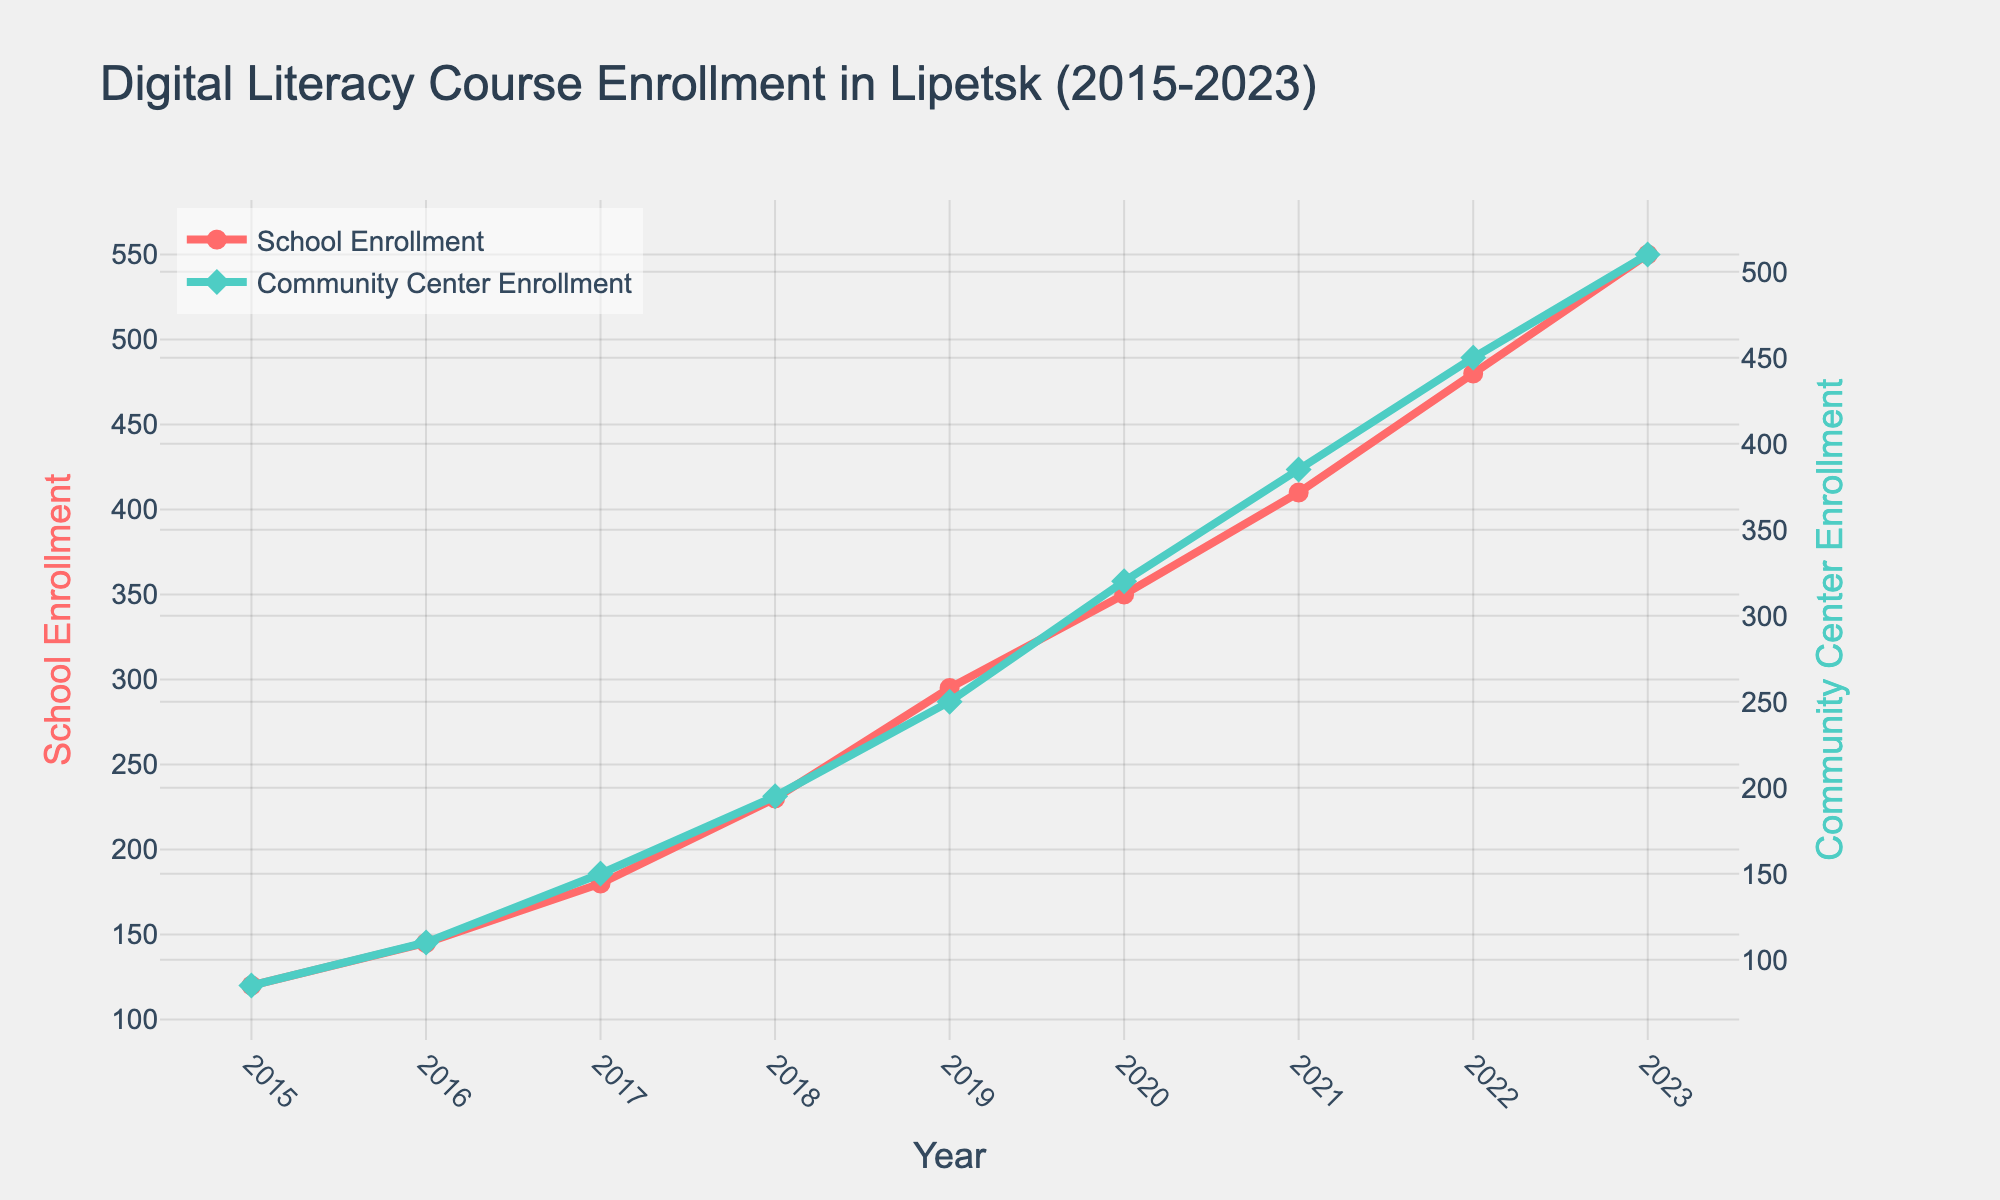Which year had the highest school enrollment? From the figure, identify the year with the peak value on the red line representing school enrollment. The highest point corresponds to 2023 with an enrollment of 550.
Answer: 2023 Which year had the highest community center enrollment? From the figure, identify the year with the peak value on the turquoise line representing community center enrollment. The highest point corresponds to 2023 with an enrollment of 510.
Answer: 2023 In which year did the school enrollment surpass 300 for the first time? Locate the red line indicating school enrollment and find the year when the value first exceeds 300. The year is 2020 with an enrollment of 350.
Answer: 2020 What is the difference between school enrollment and community center enrollment in 2023? Look at the enrollment values for both schools and community centers in 2023. The difference is 550 - 510 = 40.
Answer: 40 What was the community center enrollment in 2018? Find the value on the turquoise line for the year 2018. The community center enrollment in 2018 is 195.
Answer: 195 How does the growth in school enrollment from 2015 to 2023 compare with the growth in community center enrollment over the same period? Calculate the differences between 2023 and 2015 for both enrollment types. For schools: 550 - 120 = 430. For community centers: 510 - 85 = 425. Both show substantial growth, with schools slightly higher.
Answer: School enrollment growth: 430, Community center enrollment growth: 425 Which year saw the highest increase in school enrollment compared to the previous year? Calculate the yearly increase and find the maximum. Increments are: 
2015-2016: 145-120=25,
2016-2017: 180-145=35,
2017-2018: 230-180=50,
2018-2019: 295-230=65,
2019-2020: 350-295=55,
2020-2021: 410-350=60,
2021-2022: 480-410=70,
2022-2023: 550-480=70.
2021-2022 and 2022-2023 both had the highest increase of 70 students.
Answer: 2021-2022 and 2022-2023 What is the average annual community center enrollment from 2015 to 2023? Sum the community center enrollments from each year and divide by the number of years (9). The sum is 85+110+150+195+250+320+385+450+510 = 2455. The average is 2455/9 ≈ 272.8.
Answer: 272.8 Which enrollment was higher in 2017, school or community center? Compare the values for the year 2017. School enrollment is 180 and community center enrollment is 150. Hence, school enrollment was higher.
Answer: School enrollment Between which consecutive years did community center enrollment grow the most? Calculate the year-over-year changes for community center enrollments and find the maximum increment. 
2015-2016: 110-85=25,
2016-2017: 150-110=40,
2017-2018: 195-150=45,
2018-2019: 250-195=55,
2019-2020: 320-250=70,
2020-2021: 385-320=65,
2021-2022: 450-385=65,
2022-2023: 510-450=60.
2019-2020 had the highest increase of 70 students.
Answer: 2019-2020 